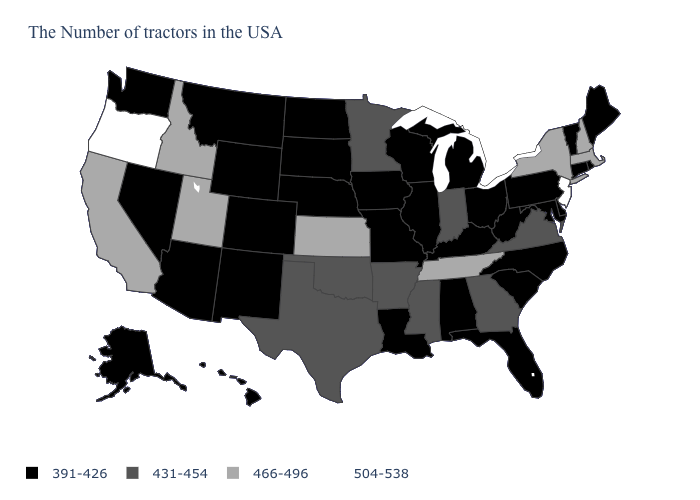What is the value of Arizona?
Answer briefly. 391-426. What is the lowest value in the USA?
Short answer required. 391-426. What is the highest value in the USA?
Keep it brief. 504-538. What is the value of Nevada?
Be succinct. 391-426. What is the value of Wisconsin?
Keep it brief. 391-426. What is the highest value in the USA?
Concise answer only. 504-538. Does California have a higher value than Colorado?
Write a very short answer. Yes. Which states have the highest value in the USA?
Answer briefly. New Jersey, Oregon. Does Oklahoma have the highest value in the USA?
Short answer required. No. What is the highest value in the Northeast ?
Be succinct. 504-538. What is the value of Mississippi?
Keep it brief. 431-454. What is the value of North Carolina?
Concise answer only. 391-426. Does Oregon have the highest value in the West?
Be succinct. Yes. Which states have the highest value in the USA?
Short answer required. New Jersey, Oregon. 